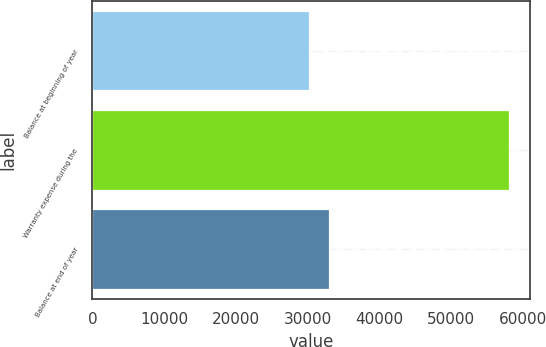<chart> <loc_0><loc_0><loc_500><loc_500><bar_chart><fcel>Balance at beginning of year<fcel>Warranty expense during the<fcel>Balance at end of year<nl><fcel>30144<fcel>58100<fcel>32939.6<nl></chart> 